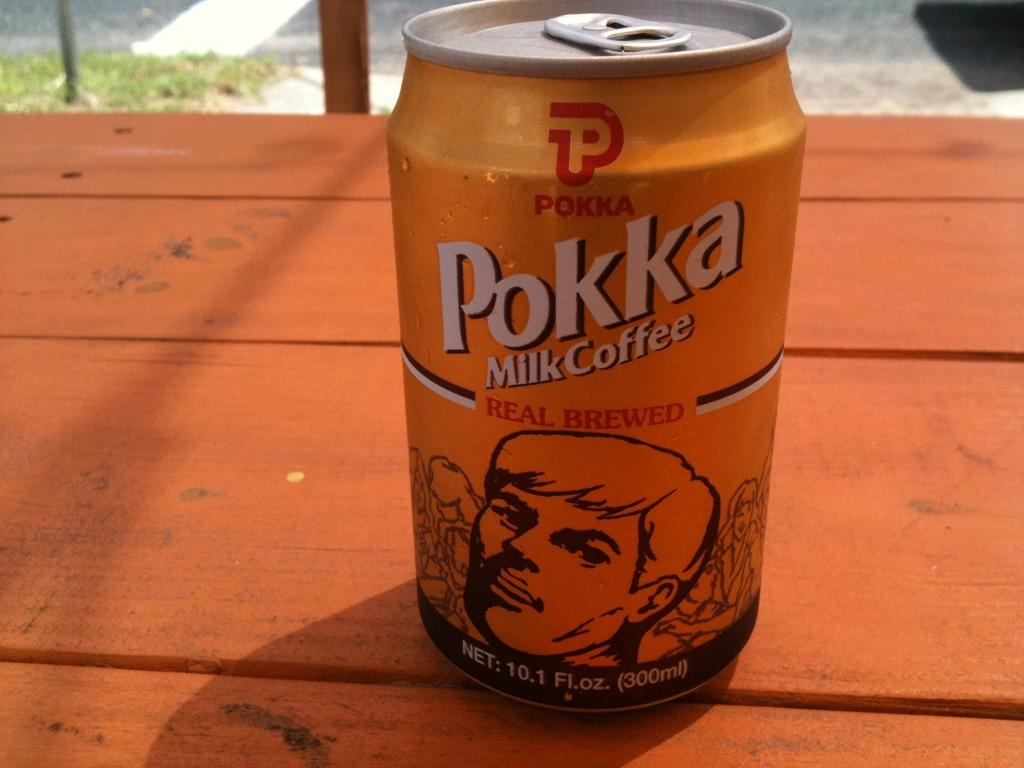<image>
Summarize the visual content of the image. A can of Pokka Milk Coffee sits on top of a wooden table 